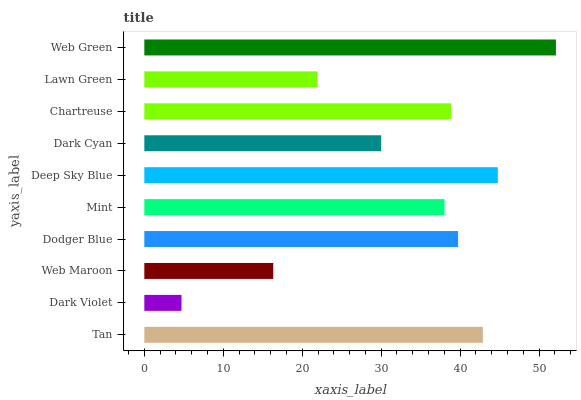Is Dark Violet the minimum?
Answer yes or no. Yes. Is Web Green the maximum?
Answer yes or no. Yes. Is Web Maroon the minimum?
Answer yes or no. No. Is Web Maroon the maximum?
Answer yes or no. No. Is Web Maroon greater than Dark Violet?
Answer yes or no. Yes. Is Dark Violet less than Web Maroon?
Answer yes or no. Yes. Is Dark Violet greater than Web Maroon?
Answer yes or no. No. Is Web Maroon less than Dark Violet?
Answer yes or no. No. Is Chartreuse the high median?
Answer yes or no. Yes. Is Mint the low median?
Answer yes or no. Yes. Is Tan the high median?
Answer yes or no. No. Is Dodger Blue the low median?
Answer yes or no. No. 